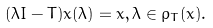<formula> <loc_0><loc_0><loc_500><loc_500>( \lambda I - T ) x ( \lambda ) = x , \lambda \in \rho _ { T } ( x ) .</formula> 